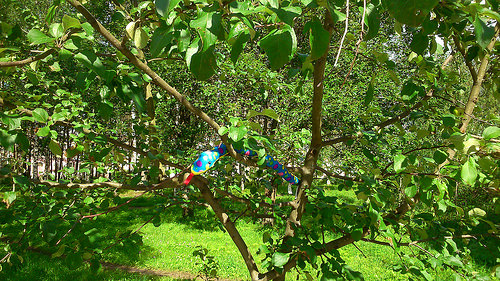<image>
Can you confirm if the birds is on the tree? Yes. Looking at the image, I can see the birds is positioned on top of the tree, with the tree providing support. 